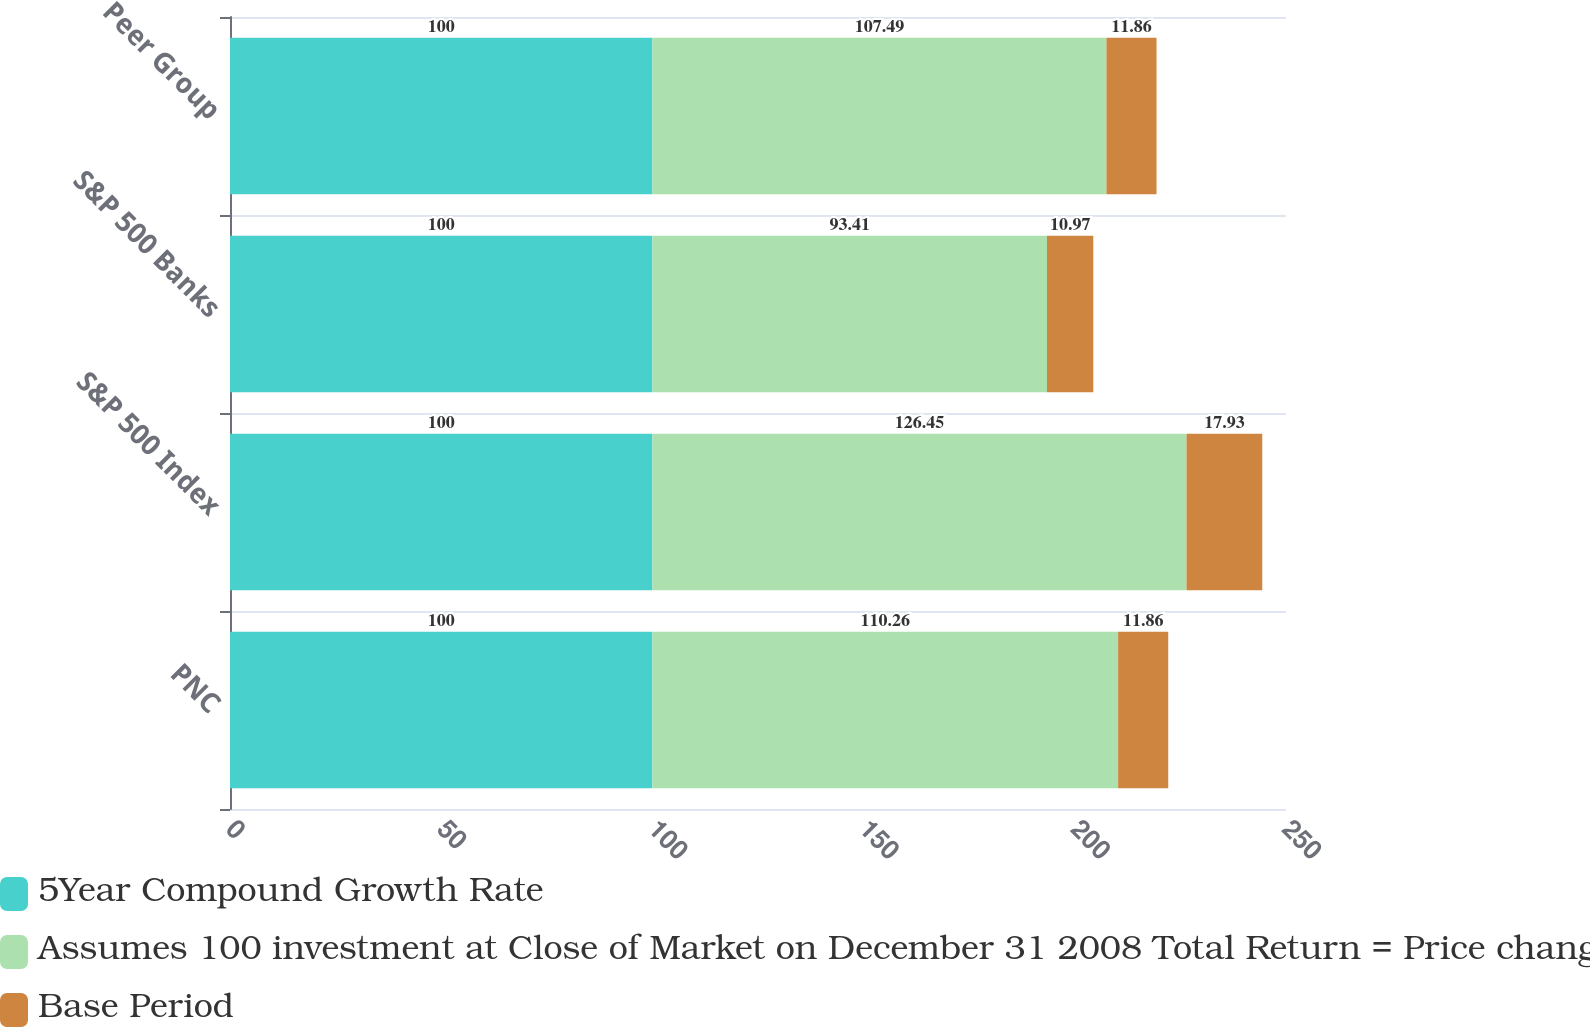Convert chart to OTSL. <chart><loc_0><loc_0><loc_500><loc_500><stacked_bar_chart><ecel><fcel>PNC<fcel>S&P 500 Index<fcel>S&P 500 Banks<fcel>Peer Group<nl><fcel>5Year Compound Growth Rate<fcel>100<fcel>100<fcel>100<fcel>100<nl><fcel>Assumes 100 investment at Close of Market on December 31 2008 Total Return = Price change plus reinvestment of dividends<fcel>110.26<fcel>126.45<fcel>93.41<fcel>107.49<nl><fcel>Base Period<fcel>11.86<fcel>17.93<fcel>10.97<fcel>11.86<nl></chart> 